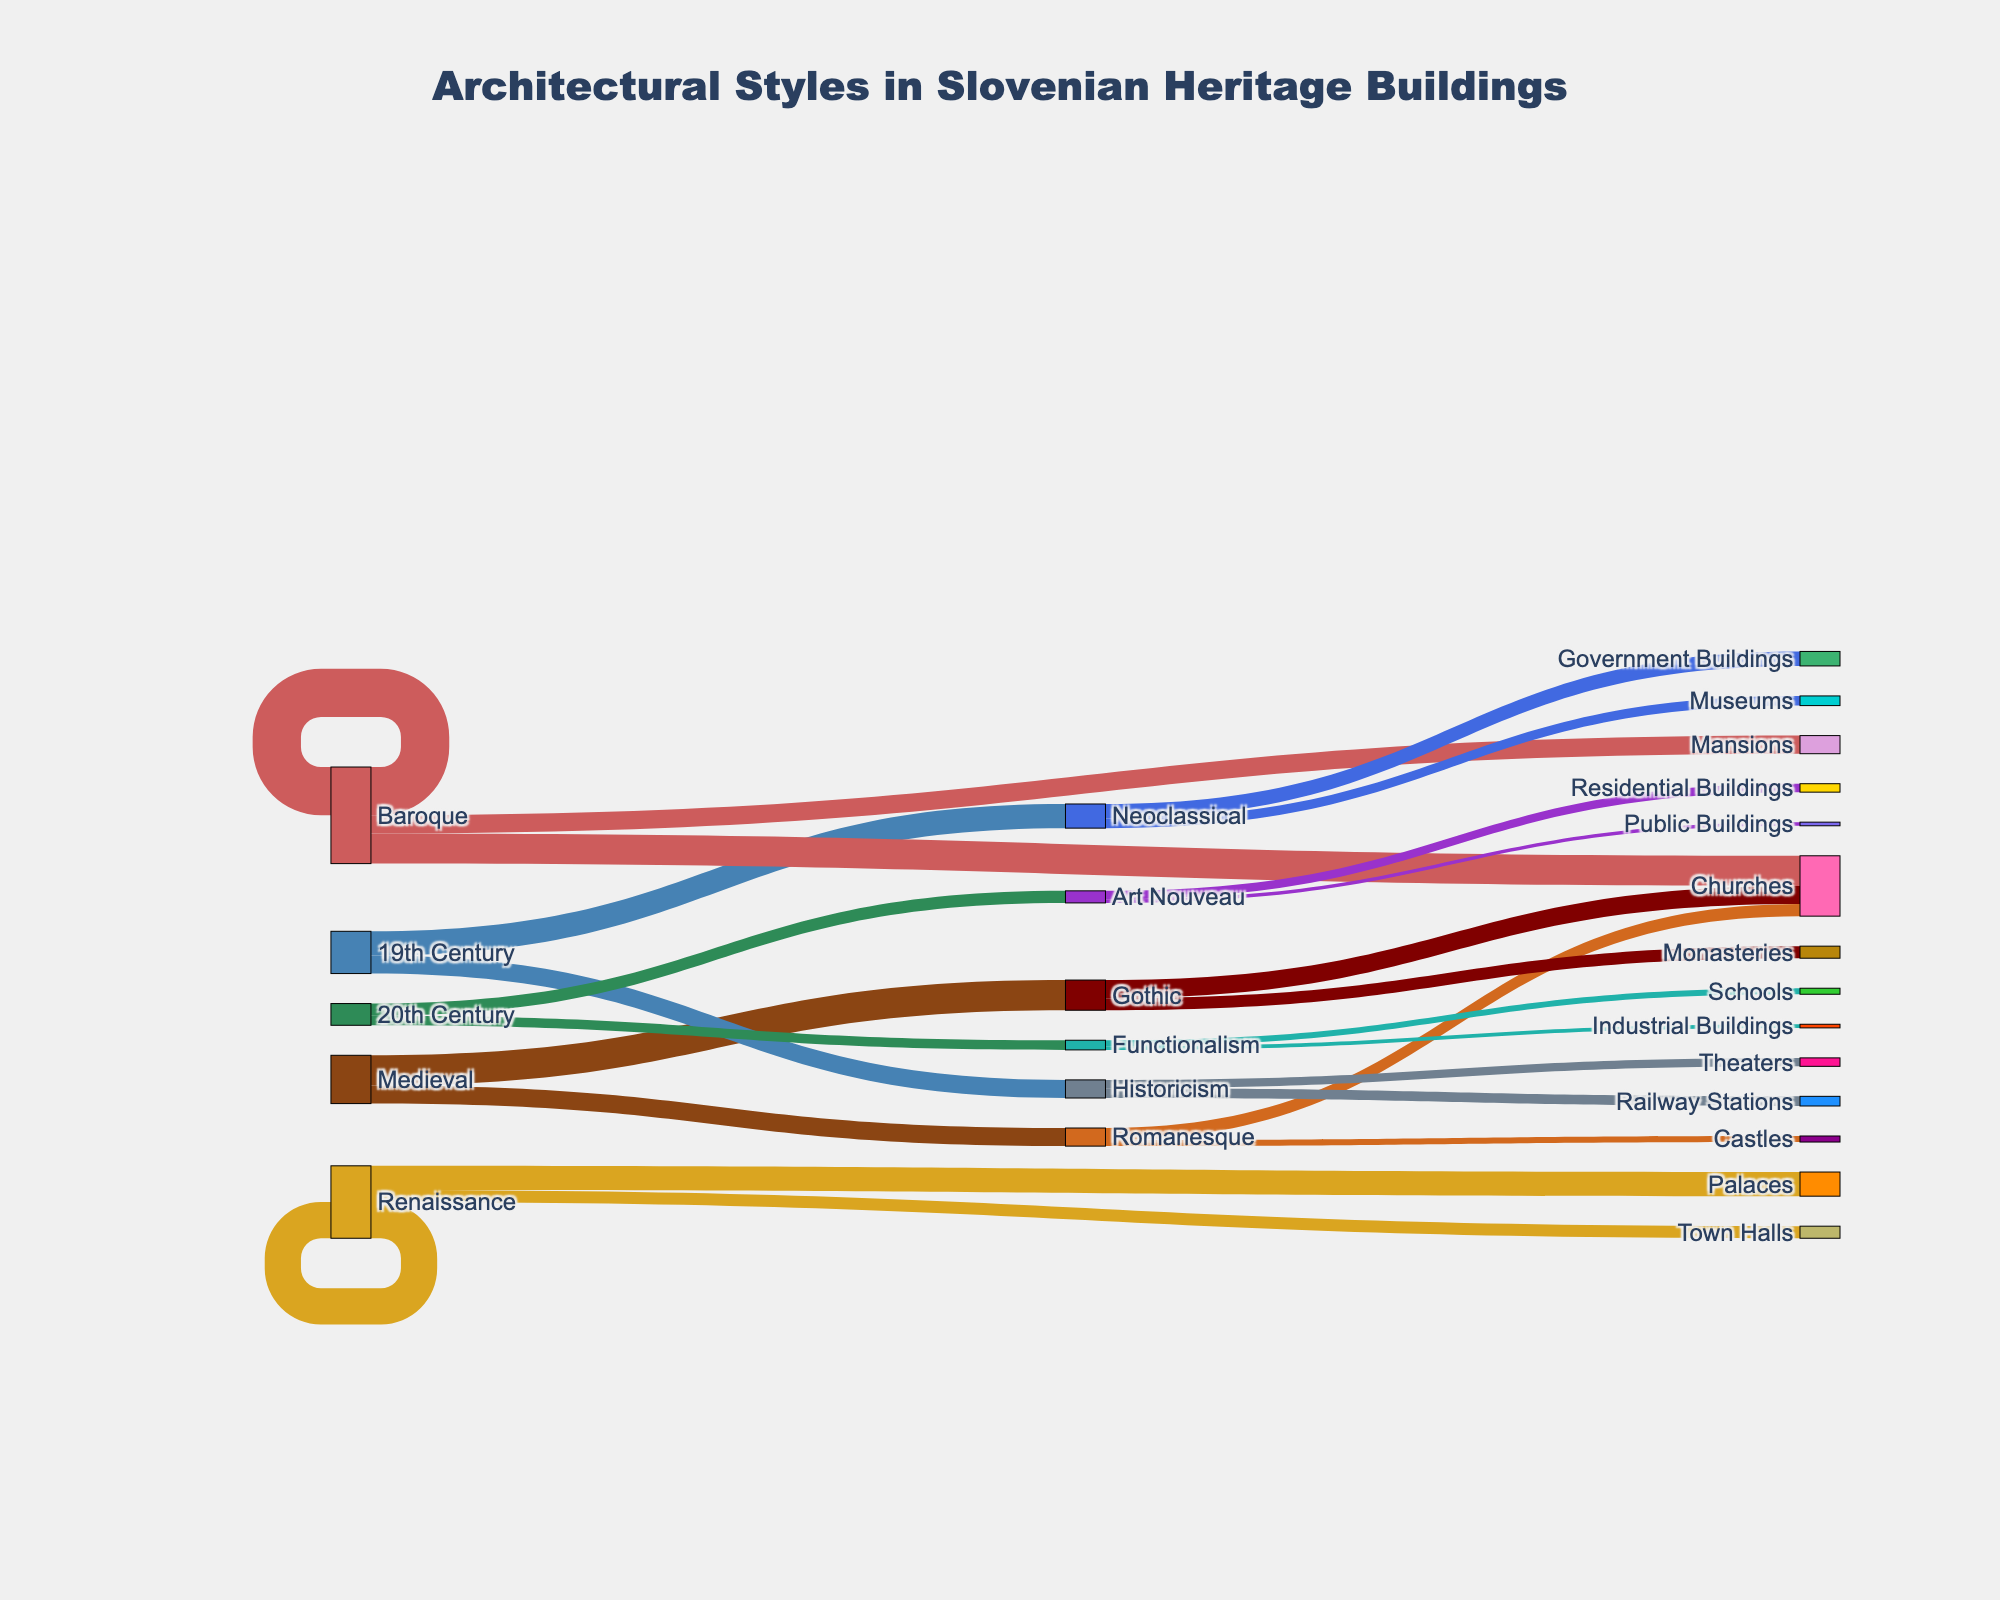What historical period has the highest value in Slovenian heritage buildings? By observing the bars' lengths from the first column which represent historical periods, we can determine which period has the highest value. The "Baroque" period has a value of 40, which is the highest among all historical periods.
Answer: Baroque How many buildings are categorized under the Gothic architectural style? To find this, sum up the values that target "Gothic" from the breakdown of the medieval period. The Gothic style has sub-values of 15 (Churches) and 10 (Monasteries), totaling 25.
Answer: 25 Which architectural style emerged from the most recent historical period depicted in the diagram? The most recent historical period depicted is the "20th Century". From this period, "Art Nouveau" and "Functionalism" emerged with values of 10 and 8 respectively.
Answer: Art Nouveau, Functionalism What is the total number of buildings under the "Renaissance" architectural style? Sum the values leading to "Renaissance". The Renaissance style has values of 20 (Palaces) and 10 (Town Halls), giving a total of 30.
Answer: 30 Compare the number of buildings under "Neoclassical" versus "Functionalism". Which has more and by how much? From the diagram, "Neoclassical" has values of 12 (Government Buildings) and 8 (Museums), totaling 20. "Functionalism" has values of 5 (Schools) and 3 (Industrial Buildings), totaling 8. Neoclassical has more by 12 buildings.
Answer: Neoclassical, 12 What type of buildings is most common under the "Baroque" architectural style? By examining the targets of "Baroque" and comparing their values, "Churches" with a value of 25 is more common than "Mansions" with a value of 15.
Answer: Churches How many buildings categorized as "Churches" originate from the "Medieval" period? From the targets of the "Medieval" period, "Churches" have values of 10 (Romanesque) and 15 (Gothic), totaling 25.
Answer: 25 Which two stylistic periods have the smallest contributions to Slovenian heritage buildings? Comparing the values from each period, "20th Century" with 18 and "19th Century" with 35 have the smallest contributions. Further detailing down, "Functionalism" with 8 contributes less compared to "Historicism" with 15 in the 19th century.
Answer: 20th Century, 19th Century 